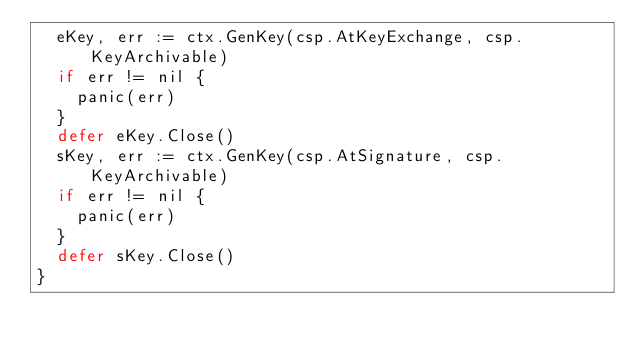<code> <loc_0><loc_0><loc_500><loc_500><_Go_>	eKey, err := ctx.GenKey(csp.AtKeyExchange, csp.KeyArchivable)
	if err != nil {
		panic(err)
	}
	defer eKey.Close()
	sKey, err := ctx.GenKey(csp.AtSignature, csp.KeyArchivable)
	if err != nil {
		panic(err)
	}
	defer sKey.Close()
}
</code> 